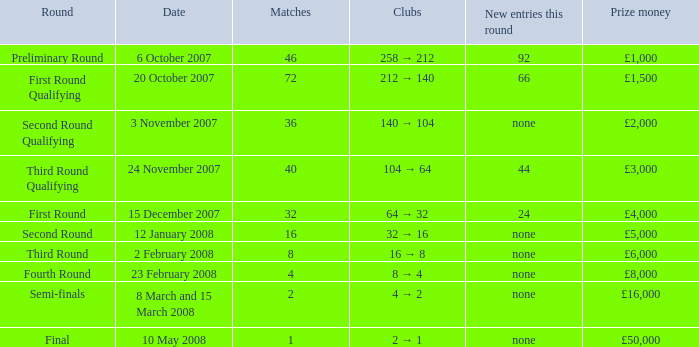How many new additions are there in this round for clubs transitioning from 2 to 1? None. 